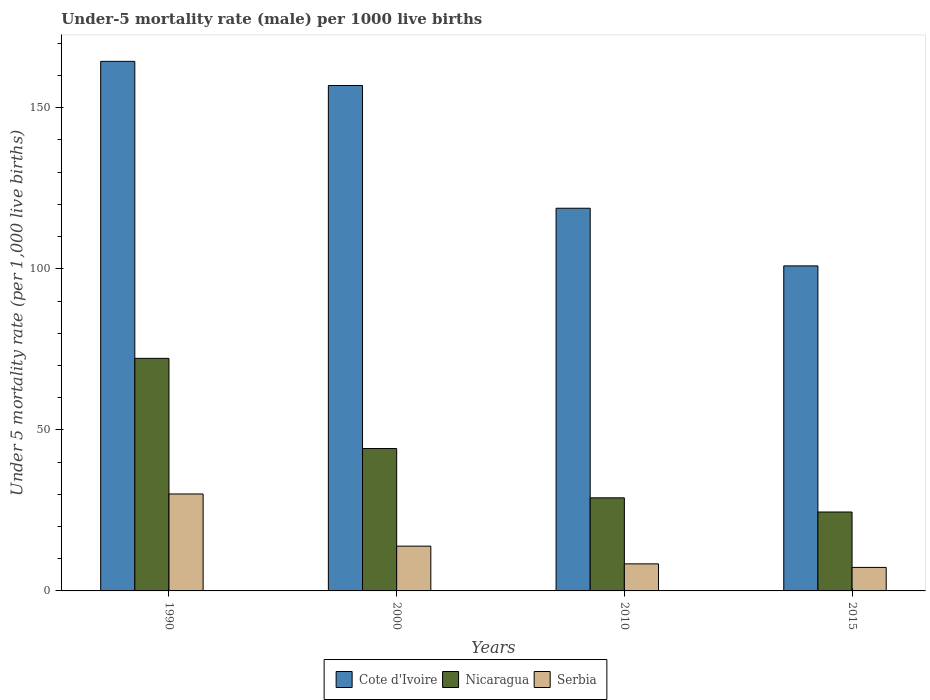Are the number of bars on each tick of the X-axis equal?
Provide a short and direct response. Yes. How many bars are there on the 1st tick from the right?
Provide a succinct answer. 3. What is the label of the 1st group of bars from the left?
Your answer should be very brief. 1990. What is the under-five mortality rate in Cote d'Ivoire in 2015?
Provide a succinct answer. 100.9. Across all years, what is the maximum under-five mortality rate in Serbia?
Provide a short and direct response. 30.1. In which year was the under-five mortality rate in Cote d'Ivoire maximum?
Ensure brevity in your answer.  1990. In which year was the under-five mortality rate in Serbia minimum?
Provide a short and direct response. 2015. What is the total under-five mortality rate in Nicaragua in the graph?
Provide a succinct answer. 169.8. What is the difference between the under-five mortality rate in Nicaragua in 2000 and the under-five mortality rate in Cote d'Ivoire in 1990?
Provide a short and direct response. -120.2. What is the average under-five mortality rate in Cote d'Ivoire per year?
Make the answer very short. 135.25. In the year 2015, what is the difference between the under-five mortality rate in Cote d'Ivoire and under-five mortality rate in Nicaragua?
Offer a very short reply. 76.4. In how many years, is the under-five mortality rate in Cote d'Ivoire greater than 90?
Your response must be concise. 4. What is the ratio of the under-five mortality rate in Cote d'Ivoire in 2000 to that in 2010?
Offer a very short reply. 1.32. Is the difference between the under-five mortality rate in Cote d'Ivoire in 1990 and 2000 greater than the difference between the under-five mortality rate in Nicaragua in 1990 and 2000?
Make the answer very short. No. What is the difference between the highest and the second highest under-five mortality rate in Nicaragua?
Give a very brief answer. 28. What is the difference between the highest and the lowest under-five mortality rate in Cote d'Ivoire?
Give a very brief answer. 63.5. In how many years, is the under-five mortality rate in Cote d'Ivoire greater than the average under-five mortality rate in Cote d'Ivoire taken over all years?
Keep it short and to the point. 2. What does the 2nd bar from the left in 2015 represents?
Your answer should be compact. Nicaragua. What does the 2nd bar from the right in 2015 represents?
Give a very brief answer. Nicaragua. Is it the case that in every year, the sum of the under-five mortality rate in Cote d'Ivoire and under-five mortality rate in Serbia is greater than the under-five mortality rate in Nicaragua?
Offer a terse response. Yes. How many bars are there?
Your answer should be compact. 12. Are all the bars in the graph horizontal?
Your response must be concise. No. Are the values on the major ticks of Y-axis written in scientific E-notation?
Provide a succinct answer. No. What is the title of the graph?
Offer a terse response. Under-5 mortality rate (male) per 1000 live births. Does "Cuba" appear as one of the legend labels in the graph?
Ensure brevity in your answer.  No. What is the label or title of the Y-axis?
Offer a terse response. Under 5 mortality rate (per 1,0 live births). What is the Under 5 mortality rate (per 1,000 live births) in Cote d'Ivoire in 1990?
Give a very brief answer. 164.4. What is the Under 5 mortality rate (per 1,000 live births) in Nicaragua in 1990?
Give a very brief answer. 72.2. What is the Under 5 mortality rate (per 1,000 live births) in Serbia in 1990?
Your response must be concise. 30.1. What is the Under 5 mortality rate (per 1,000 live births) in Cote d'Ivoire in 2000?
Ensure brevity in your answer.  156.9. What is the Under 5 mortality rate (per 1,000 live births) of Nicaragua in 2000?
Keep it short and to the point. 44.2. What is the Under 5 mortality rate (per 1,000 live births) of Cote d'Ivoire in 2010?
Provide a short and direct response. 118.8. What is the Under 5 mortality rate (per 1,000 live births) of Nicaragua in 2010?
Make the answer very short. 28.9. What is the Under 5 mortality rate (per 1,000 live births) of Cote d'Ivoire in 2015?
Provide a succinct answer. 100.9. What is the Under 5 mortality rate (per 1,000 live births) in Serbia in 2015?
Your response must be concise. 7.3. Across all years, what is the maximum Under 5 mortality rate (per 1,000 live births) in Cote d'Ivoire?
Ensure brevity in your answer.  164.4. Across all years, what is the maximum Under 5 mortality rate (per 1,000 live births) of Nicaragua?
Ensure brevity in your answer.  72.2. Across all years, what is the maximum Under 5 mortality rate (per 1,000 live births) of Serbia?
Offer a terse response. 30.1. Across all years, what is the minimum Under 5 mortality rate (per 1,000 live births) of Cote d'Ivoire?
Your response must be concise. 100.9. What is the total Under 5 mortality rate (per 1,000 live births) of Cote d'Ivoire in the graph?
Your answer should be very brief. 541. What is the total Under 5 mortality rate (per 1,000 live births) of Nicaragua in the graph?
Your answer should be very brief. 169.8. What is the total Under 5 mortality rate (per 1,000 live births) in Serbia in the graph?
Your answer should be compact. 59.7. What is the difference between the Under 5 mortality rate (per 1,000 live births) of Cote d'Ivoire in 1990 and that in 2000?
Give a very brief answer. 7.5. What is the difference between the Under 5 mortality rate (per 1,000 live births) of Cote d'Ivoire in 1990 and that in 2010?
Provide a short and direct response. 45.6. What is the difference between the Under 5 mortality rate (per 1,000 live births) of Nicaragua in 1990 and that in 2010?
Your answer should be compact. 43.3. What is the difference between the Under 5 mortality rate (per 1,000 live births) of Serbia in 1990 and that in 2010?
Your answer should be very brief. 21.7. What is the difference between the Under 5 mortality rate (per 1,000 live births) in Cote d'Ivoire in 1990 and that in 2015?
Keep it short and to the point. 63.5. What is the difference between the Under 5 mortality rate (per 1,000 live births) of Nicaragua in 1990 and that in 2015?
Offer a terse response. 47.7. What is the difference between the Under 5 mortality rate (per 1,000 live births) of Serbia in 1990 and that in 2015?
Your answer should be very brief. 22.8. What is the difference between the Under 5 mortality rate (per 1,000 live births) of Cote d'Ivoire in 2000 and that in 2010?
Give a very brief answer. 38.1. What is the difference between the Under 5 mortality rate (per 1,000 live births) in Serbia in 2000 and that in 2010?
Keep it short and to the point. 5.5. What is the difference between the Under 5 mortality rate (per 1,000 live births) in Cote d'Ivoire in 2000 and that in 2015?
Ensure brevity in your answer.  56. What is the difference between the Under 5 mortality rate (per 1,000 live births) of Nicaragua in 2000 and that in 2015?
Provide a succinct answer. 19.7. What is the difference between the Under 5 mortality rate (per 1,000 live births) of Cote d'Ivoire in 2010 and that in 2015?
Ensure brevity in your answer.  17.9. What is the difference between the Under 5 mortality rate (per 1,000 live births) in Cote d'Ivoire in 1990 and the Under 5 mortality rate (per 1,000 live births) in Nicaragua in 2000?
Your answer should be compact. 120.2. What is the difference between the Under 5 mortality rate (per 1,000 live births) in Cote d'Ivoire in 1990 and the Under 5 mortality rate (per 1,000 live births) in Serbia in 2000?
Your response must be concise. 150.5. What is the difference between the Under 5 mortality rate (per 1,000 live births) in Nicaragua in 1990 and the Under 5 mortality rate (per 1,000 live births) in Serbia in 2000?
Keep it short and to the point. 58.3. What is the difference between the Under 5 mortality rate (per 1,000 live births) in Cote d'Ivoire in 1990 and the Under 5 mortality rate (per 1,000 live births) in Nicaragua in 2010?
Provide a succinct answer. 135.5. What is the difference between the Under 5 mortality rate (per 1,000 live births) in Cote d'Ivoire in 1990 and the Under 5 mortality rate (per 1,000 live births) in Serbia in 2010?
Offer a terse response. 156. What is the difference between the Under 5 mortality rate (per 1,000 live births) of Nicaragua in 1990 and the Under 5 mortality rate (per 1,000 live births) of Serbia in 2010?
Your answer should be very brief. 63.8. What is the difference between the Under 5 mortality rate (per 1,000 live births) in Cote d'Ivoire in 1990 and the Under 5 mortality rate (per 1,000 live births) in Nicaragua in 2015?
Your response must be concise. 139.9. What is the difference between the Under 5 mortality rate (per 1,000 live births) of Cote d'Ivoire in 1990 and the Under 5 mortality rate (per 1,000 live births) of Serbia in 2015?
Make the answer very short. 157.1. What is the difference between the Under 5 mortality rate (per 1,000 live births) in Nicaragua in 1990 and the Under 5 mortality rate (per 1,000 live births) in Serbia in 2015?
Offer a terse response. 64.9. What is the difference between the Under 5 mortality rate (per 1,000 live births) in Cote d'Ivoire in 2000 and the Under 5 mortality rate (per 1,000 live births) in Nicaragua in 2010?
Keep it short and to the point. 128. What is the difference between the Under 5 mortality rate (per 1,000 live births) of Cote d'Ivoire in 2000 and the Under 5 mortality rate (per 1,000 live births) of Serbia in 2010?
Offer a very short reply. 148.5. What is the difference between the Under 5 mortality rate (per 1,000 live births) of Nicaragua in 2000 and the Under 5 mortality rate (per 1,000 live births) of Serbia in 2010?
Offer a terse response. 35.8. What is the difference between the Under 5 mortality rate (per 1,000 live births) in Cote d'Ivoire in 2000 and the Under 5 mortality rate (per 1,000 live births) in Nicaragua in 2015?
Make the answer very short. 132.4. What is the difference between the Under 5 mortality rate (per 1,000 live births) of Cote d'Ivoire in 2000 and the Under 5 mortality rate (per 1,000 live births) of Serbia in 2015?
Provide a succinct answer. 149.6. What is the difference between the Under 5 mortality rate (per 1,000 live births) of Nicaragua in 2000 and the Under 5 mortality rate (per 1,000 live births) of Serbia in 2015?
Provide a short and direct response. 36.9. What is the difference between the Under 5 mortality rate (per 1,000 live births) in Cote d'Ivoire in 2010 and the Under 5 mortality rate (per 1,000 live births) in Nicaragua in 2015?
Offer a very short reply. 94.3. What is the difference between the Under 5 mortality rate (per 1,000 live births) in Cote d'Ivoire in 2010 and the Under 5 mortality rate (per 1,000 live births) in Serbia in 2015?
Provide a short and direct response. 111.5. What is the difference between the Under 5 mortality rate (per 1,000 live births) of Nicaragua in 2010 and the Under 5 mortality rate (per 1,000 live births) of Serbia in 2015?
Keep it short and to the point. 21.6. What is the average Under 5 mortality rate (per 1,000 live births) of Cote d'Ivoire per year?
Offer a very short reply. 135.25. What is the average Under 5 mortality rate (per 1,000 live births) in Nicaragua per year?
Your response must be concise. 42.45. What is the average Under 5 mortality rate (per 1,000 live births) of Serbia per year?
Make the answer very short. 14.93. In the year 1990, what is the difference between the Under 5 mortality rate (per 1,000 live births) in Cote d'Ivoire and Under 5 mortality rate (per 1,000 live births) in Nicaragua?
Ensure brevity in your answer.  92.2. In the year 1990, what is the difference between the Under 5 mortality rate (per 1,000 live births) of Cote d'Ivoire and Under 5 mortality rate (per 1,000 live births) of Serbia?
Keep it short and to the point. 134.3. In the year 1990, what is the difference between the Under 5 mortality rate (per 1,000 live births) of Nicaragua and Under 5 mortality rate (per 1,000 live births) of Serbia?
Ensure brevity in your answer.  42.1. In the year 2000, what is the difference between the Under 5 mortality rate (per 1,000 live births) of Cote d'Ivoire and Under 5 mortality rate (per 1,000 live births) of Nicaragua?
Give a very brief answer. 112.7. In the year 2000, what is the difference between the Under 5 mortality rate (per 1,000 live births) in Cote d'Ivoire and Under 5 mortality rate (per 1,000 live births) in Serbia?
Ensure brevity in your answer.  143. In the year 2000, what is the difference between the Under 5 mortality rate (per 1,000 live births) in Nicaragua and Under 5 mortality rate (per 1,000 live births) in Serbia?
Give a very brief answer. 30.3. In the year 2010, what is the difference between the Under 5 mortality rate (per 1,000 live births) of Cote d'Ivoire and Under 5 mortality rate (per 1,000 live births) of Nicaragua?
Give a very brief answer. 89.9. In the year 2010, what is the difference between the Under 5 mortality rate (per 1,000 live births) of Cote d'Ivoire and Under 5 mortality rate (per 1,000 live births) of Serbia?
Ensure brevity in your answer.  110.4. In the year 2010, what is the difference between the Under 5 mortality rate (per 1,000 live births) in Nicaragua and Under 5 mortality rate (per 1,000 live births) in Serbia?
Keep it short and to the point. 20.5. In the year 2015, what is the difference between the Under 5 mortality rate (per 1,000 live births) in Cote d'Ivoire and Under 5 mortality rate (per 1,000 live births) in Nicaragua?
Your answer should be very brief. 76.4. In the year 2015, what is the difference between the Under 5 mortality rate (per 1,000 live births) of Cote d'Ivoire and Under 5 mortality rate (per 1,000 live births) of Serbia?
Give a very brief answer. 93.6. In the year 2015, what is the difference between the Under 5 mortality rate (per 1,000 live births) of Nicaragua and Under 5 mortality rate (per 1,000 live births) of Serbia?
Your answer should be very brief. 17.2. What is the ratio of the Under 5 mortality rate (per 1,000 live births) in Cote d'Ivoire in 1990 to that in 2000?
Offer a very short reply. 1.05. What is the ratio of the Under 5 mortality rate (per 1,000 live births) in Nicaragua in 1990 to that in 2000?
Make the answer very short. 1.63. What is the ratio of the Under 5 mortality rate (per 1,000 live births) in Serbia in 1990 to that in 2000?
Offer a terse response. 2.17. What is the ratio of the Under 5 mortality rate (per 1,000 live births) of Cote d'Ivoire in 1990 to that in 2010?
Your answer should be very brief. 1.38. What is the ratio of the Under 5 mortality rate (per 1,000 live births) in Nicaragua in 1990 to that in 2010?
Offer a very short reply. 2.5. What is the ratio of the Under 5 mortality rate (per 1,000 live births) of Serbia in 1990 to that in 2010?
Make the answer very short. 3.58. What is the ratio of the Under 5 mortality rate (per 1,000 live births) of Cote d'Ivoire in 1990 to that in 2015?
Provide a succinct answer. 1.63. What is the ratio of the Under 5 mortality rate (per 1,000 live births) of Nicaragua in 1990 to that in 2015?
Keep it short and to the point. 2.95. What is the ratio of the Under 5 mortality rate (per 1,000 live births) of Serbia in 1990 to that in 2015?
Provide a short and direct response. 4.12. What is the ratio of the Under 5 mortality rate (per 1,000 live births) of Cote d'Ivoire in 2000 to that in 2010?
Ensure brevity in your answer.  1.32. What is the ratio of the Under 5 mortality rate (per 1,000 live births) in Nicaragua in 2000 to that in 2010?
Your response must be concise. 1.53. What is the ratio of the Under 5 mortality rate (per 1,000 live births) in Serbia in 2000 to that in 2010?
Provide a short and direct response. 1.65. What is the ratio of the Under 5 mortality rate (per 1,000 live births) of Cote d'Ivoire in 2000 to that in 2015?
Give a very brief answer. 1.55. What is the ratio of the Under 5 mortality rate (per 1,000 live births) of Nicaragua in 2000 to that in 2015?
Provide a succinct answer. 1.8. What is the ratio of the Under 5 mortality rate (per 1,000 live births) in Serbia in 2000 to that in 2015?
Your answer should be very brief. 1.9. What is the ratio of the Under 5 mortality rate (per 1,000 live births) in Cote d'Ivoire in 2010 to that in 2015?
Provide a succinct answer. 1.18. What is the ratio of the Under 5 mortality rate (per 1,000 live births) of Nicaragua in 2010 to that in 2015?
Your answer should be compact. 1.18. What is the ratio of the Under 5 mortality rate (per 1,000 live births) of Serbia in 2010 to that in 2015?
Make the answer very short. 1.15. What is the difference between the highest and the second highest Under 5 mortality rate (per 1,000 live births) in Nicaragua?
Keep it short and to the point. 28. What is the difference between the highest and the lowest Under 5 mortality rate (per 1,000 live births) of Cote d'Ivoire?
Ensure brevity in your answer.  63.5. What is the difference between the highest and the lowest Under 5 mortality rate (per 1,000 live births) in Nicaragua?
Provide a succinct answer. 47.7. What is the difference between the highest and the lowest Under 5 mortality rate (per 1,000 live births) of Serbia?
Give a very brief answer. 22.8. 